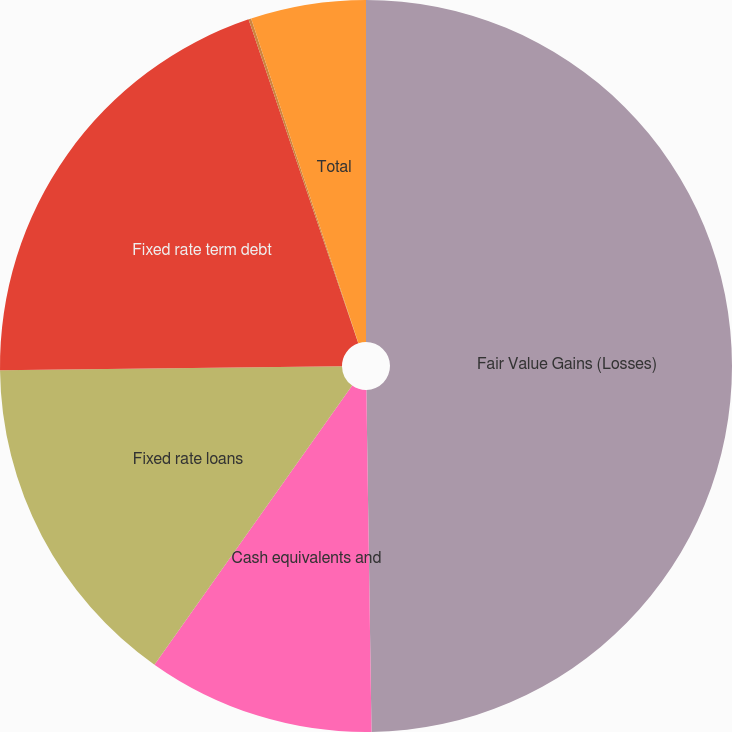Convert chart to OTSL. <chart><loc_0><loc_0><loc_500><loc_500><pie_chart><fcel>Fair Value Gains (Losses)<fcel>Cash equivalents and<fcel>Fixed rate loans<fcel>Fixed rate term debt<fcel>Interest-rate swaps<fcel>Total<nl><fcel>49.76%<fcel>10.05%<fcel>15.01%<fcel>19.98%<fcel>0.12%<fcel>5.08%<nl></chart> 